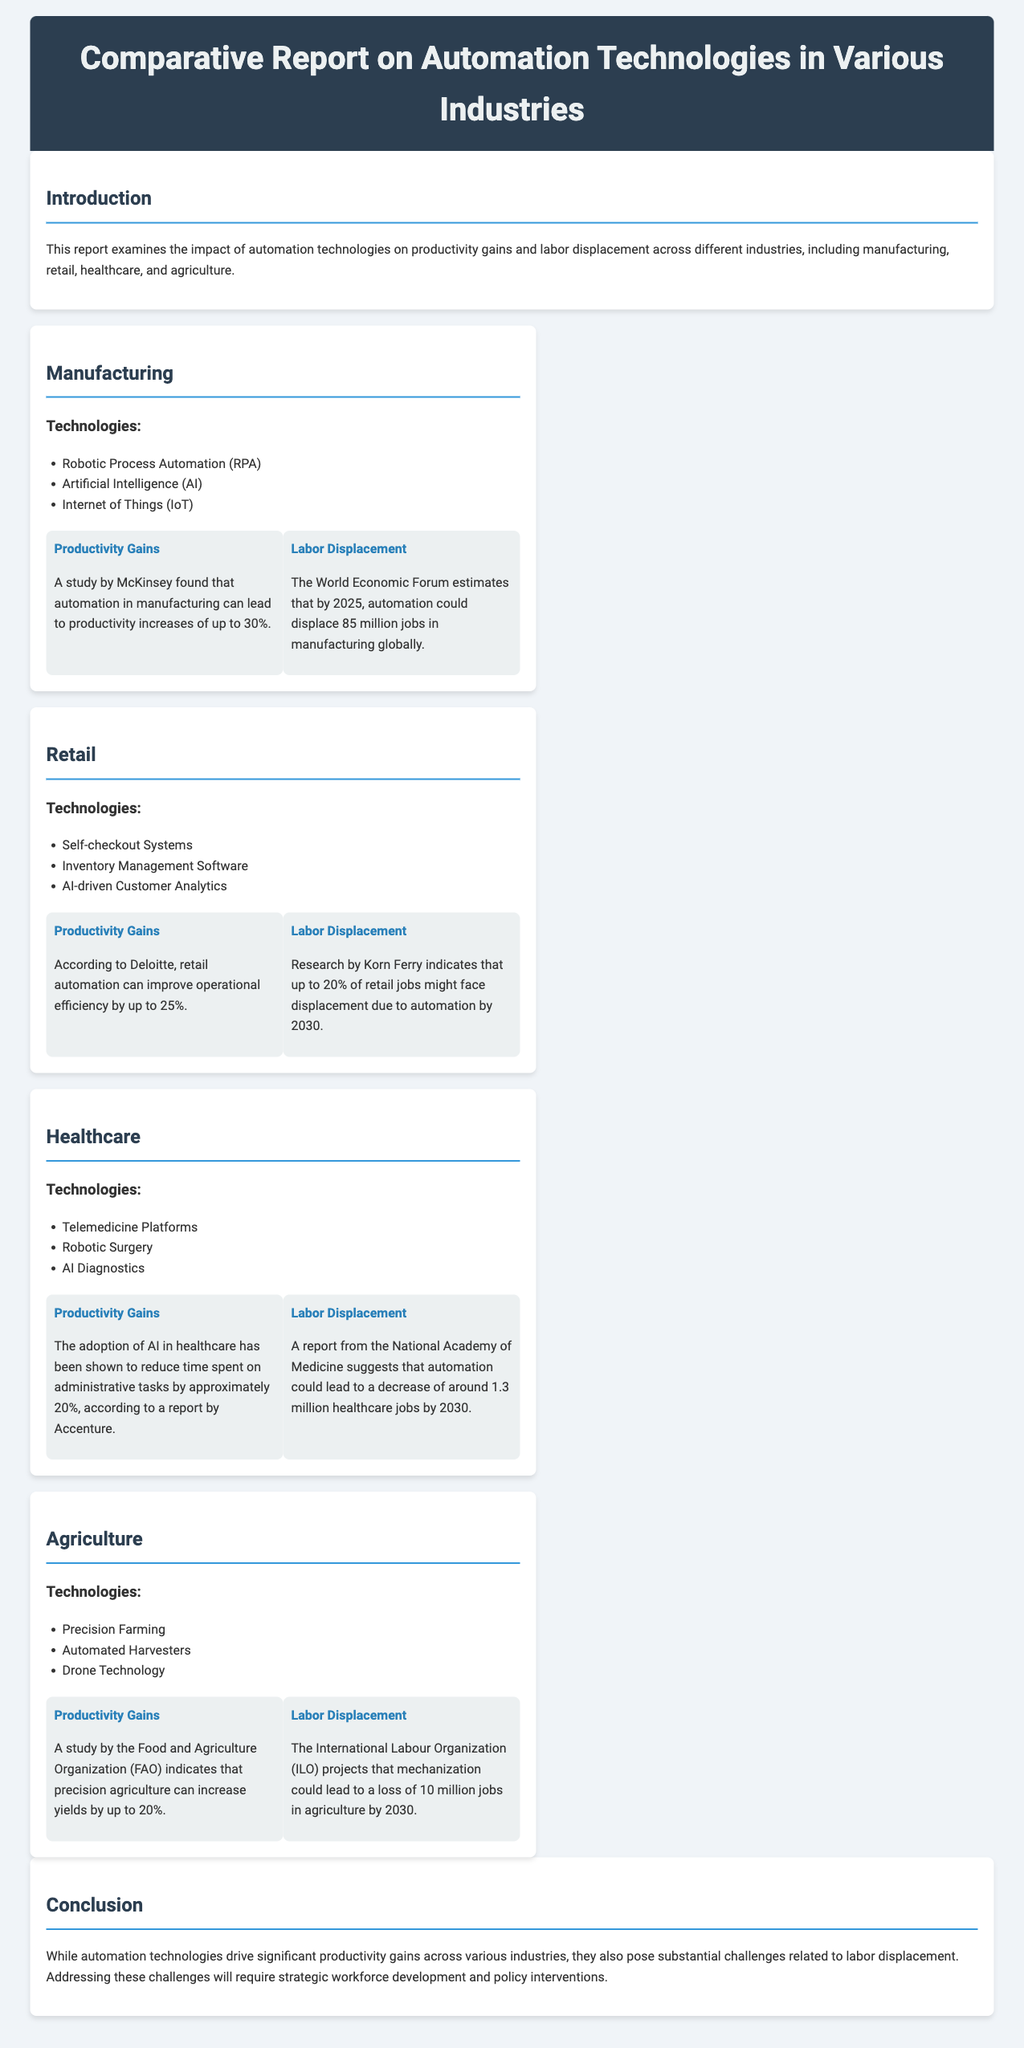What is the main subject of the report? The report examines the impact of automation technologies on productivity gains and labor displacement across different industries.
Answer: impact of automation technologies What are the productivity gains in manufacturing according to McKinsey? McKinsey found that automation in manufacturing can lead to productivity increases of up to 30%.
Answer: up to 30% What technology is associated with the retail productivity gains? Retail automation can improve operational efficiency by up to 25% according to Deloitte.
Answer: operational efficiency How many jobs might be displaced in retail by 2030 according to Korn Ferry? Up to 20% of retail jobs might face displacement due to automation by 2030, according to research by Korn Ferry.
Answer: 20% What does the FAO indicate about precision agriculture? A study by the Food and Agriculture Organization (FAO) indicates that precision agriculture can increase yields by up to 20%.
Answer: up to 20% How many healthcare jobs could be lost by 2030? Automation could lead to a decrease of around 1.3 million healthcare jobs by 2030, according to a report from the National Academy of Medicine.
Answer: 1.3 million What conclusion does the report make regarding automation technologies? The conclusion states that while automation technologies drive significant productivity gains across various industries, they pose substantial challenges related to labor displacement.
Answer: substantial challenges related to labor displacement What is a key technology in healthcare automation? Key technologies in healthcare automation include Telemedicine Platforms, Robotic Surgery, and AI Diagnostics.
Answer: Telemedicine Platforms How many manufacturing jobs might be displaced globally by 2025? The World Economic Forum estimates that by 2025, automation could displace 85 million jobs in manufacturing globally.
Answer: 85 million 